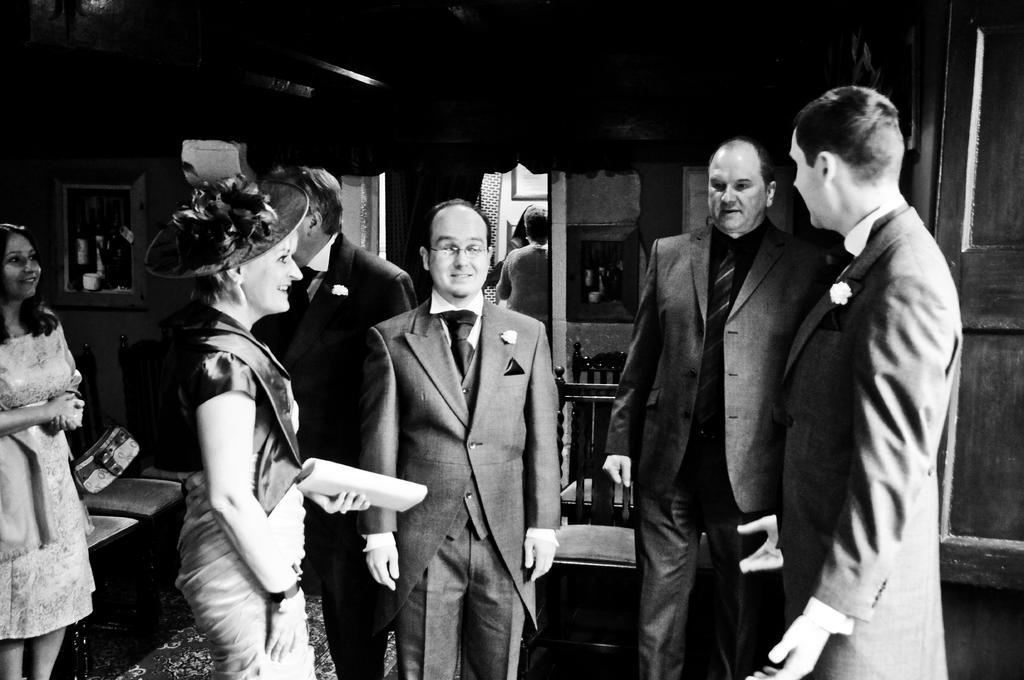In one or two sentences, can you explain what this image depicts? Black and white picture. In this picture we can see people and chairs. Pictures are on the wall. Far we can see one person is standing. Backside of this person there is a door. 